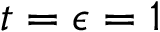Convert formula to latex. <formula><loc_0><loc_0><loc_500><loc_500>t = \epsilon = 1</formula> 